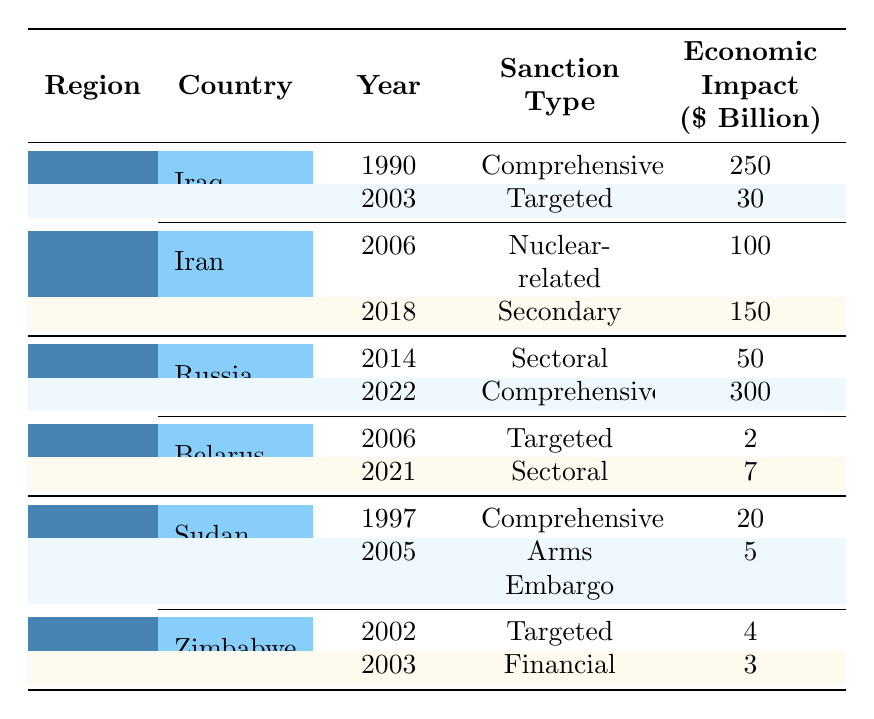What is the total economic impact of sanctions imposed on Iraq? There are two instances of sanctions on Iraq: in 1990 with an economic impact of $250 billion and in 2003 with an economic impact of $30 billion. Adding these together gives $250 billion + $30 billion = $280 billion.
Answer: 280 billion Which country had the highest economic impact from sanctions in the Eastern Europe region? In the Eastern Europe region, Russia has two sanctions: in 2014 with an impact of $50 billion and in 2022 with an impact of $300 billion. The higher value is $300 billion in 2022.
Answer: Russia Did any country in the table receive sanctions in 1997? Yes, Sudan received sanctions in 1997, which were comprehensive in nature.
Answer: Yes What is the total economic impact of all sanctions imposed on Iran? Iran has two sanctions: one in 2006 with an impact of $100 billion and another in 2018 with an impact of $150 billion. Summing these gives $100 billion + $150 billion = $250 billion.
Answer: 250 billion Is there a country in Africa that received more than $20 billion in economic impact from sanctions? No, the highest economic impact from sanctions in Africa is $20 billion from Sudan in 1997, and no other country in Africa reached this amount.
Answer: No Which imposition entity caused the most economic impact on Russia through sanctions? Russland’s sanctions were imposed by the EU in 2014 ($50 billion) and by multiple countries in 2022 ($300 billion). The highest impact is from the 2022 sanctions by multiple countries.
Answer: Multiple countries What is the average economic impact from sanctions imposed on Belarus? Belarus has two sanctions: one in 2006 with $2 billion and another in 2021 with $7 billion. Their average can be calculated as ($2 billion + $7 billion) / 2 = $4.5 billion.
Answer: 4.5 billion Which year had the most total economic impact from sanctions across the table? The years in the table show the following impacts: 1990 ($250 billion), 2003 ($30 billion), 2006 ($100 billion), 2014 ($50 billion), 2018 ($150 billion), and 2022 ($300 billion). The highest is from 2022 with $300 billion.
Answer: 2022 How many countries in the Middle East faced sanctions? The table lists two countries in the Middle East - Iraq and Iran.
Answer: 2 Which sanction type was imposed on Sudan in 1997? The sanction type imposed on Sudan in 1997 was comprehensive.
Answer: Comprehensive 